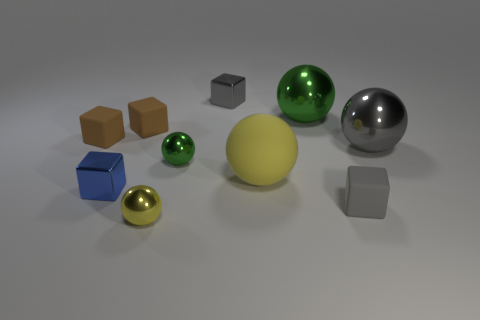There is a green sphere in front of the big gray shiny thing; is its size the same as the cube that is in front of the small blue metal object?
Provide a succinct answer. Yes. What is the material of the green thing that is the same size as the rubber ball?
Ensure brevity in your answer.  Metal. What is the large ball that is both right of the big yellow sphere and in front of the large green thing made of?
Provide a succinct answer. Metal. Are any large green matte cubes visible?
Your answer should be very brief. No. Is the color of the big rubber sphere the same as the small metallic ball in front of the small green ball?
Your answer should be very brief. Yes. There is a sphere that is the same color as the large rubber thing; what is its material?
Give a very brief answer. Metal. The small gray thing that is to the right of the big yellow sphere that is in front of the large thing on the right side of the big green object is what shape?
Give a very brief answer. Cube. What shape is the small blue thing?
Make the answer very short. Cube. There is a small shiny thing that is behind the large green shiny object; what color is it?
Make the answer very short. Gray. There is a gray object in front of the gray sphere; is it the same size as the blue metal cube?
Offer a very short reply. Yes. 